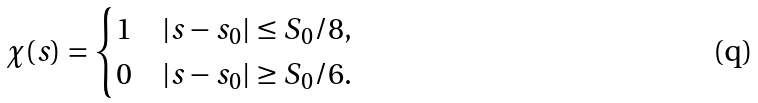Convert formula to latex. <formula><loc_0><loc_0><loc_500><loc_500>\chi ( s ) = \begin{cases} 1 & | s - s _ { 0 } | \leq S _ { 0 } / 8 , \\ 0 & | s - s _ { 0 } | \geq S _ { 0 } / 6 . \end{cases}</formula> 